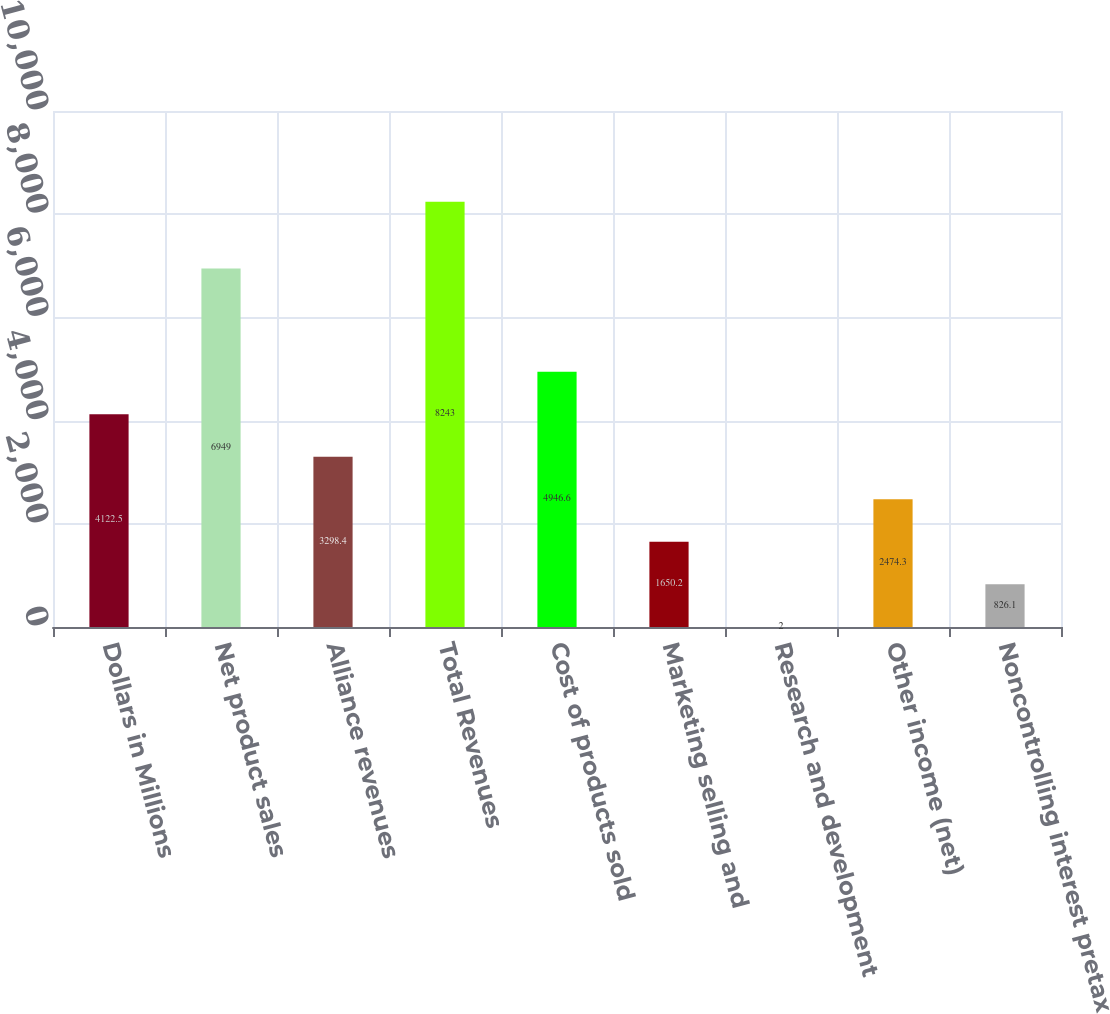<chart> <loc_0><loc_0><loc_500><loc_500><bar_chart><fcel>Dollars in Millions<fcel>Net product sales<fcel>Alliance revenues<fcel>Total Revenues<fcel>Cost of products sold<fcel>Marketing selling and<fcel>Research and development<fcel>Other income (net)<fcel>Noncontrolling interest pretax<nl><fcel>4122.5<fcel>6949<fcel>3298.4<fcel>8243<fcel>4946.6<fcel>1650.2<fcel>2<fcel>2474.3<fcel>826.1<nl></chart> 